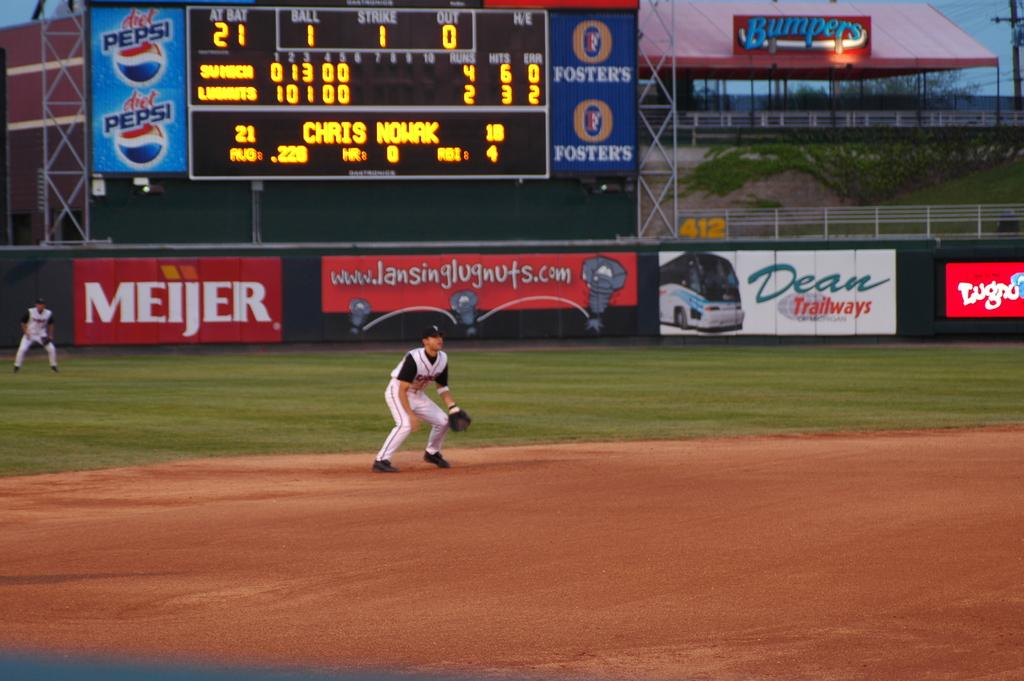<image>
Present a compact description of the photo's key features. The score in the baseball game is 4 to 2 